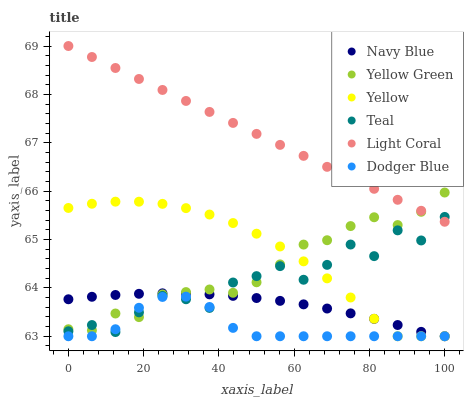Does Dodger Blue have the minimum area under the curve?
Answer yes or no. Yes. Does Light Coral have the maximum area under the curve?
Answer yes or no. Yes. Does Navy Blue have the minimum area under the curve?
Answer yes or no. No. Does Navy Blue have the maximum area under the curve?
Answer yes or no. No. Is Light Coral the smoothest?
Answer yes or no. Yes. Is Teal the roughest?
Answer yes or no. Yes. Is Navy Blue the smoothest?
Answer yes or no. No. Is Navy Blue the roughest?
Answer yes or no. No. Does Navy Blue have the lowest value?
Answer yes or no. Yes. Does Light Coral have the lowest value?
Answer yes or no. No. Does Light Coral have the highest value?
Answer yes or no. Yes. Does Navy Blue have the highest value?
Answer yes or no. No. Is Yellow less than Light Coral?
Answer yes or no. Yes. Is Light Coral greater than Yellow?
Answer yes or no. Yes. Does Yellow intersect Dodger Blue?
Answer yes or no. Yes. Is Yellow less than Dodger Blue?
Answer yes or no. No. Is Yellow greater than Dodger Blue?
Answer yes or no. No. Does Yellow intersect Light Coral?
Answer yes or no. No. 